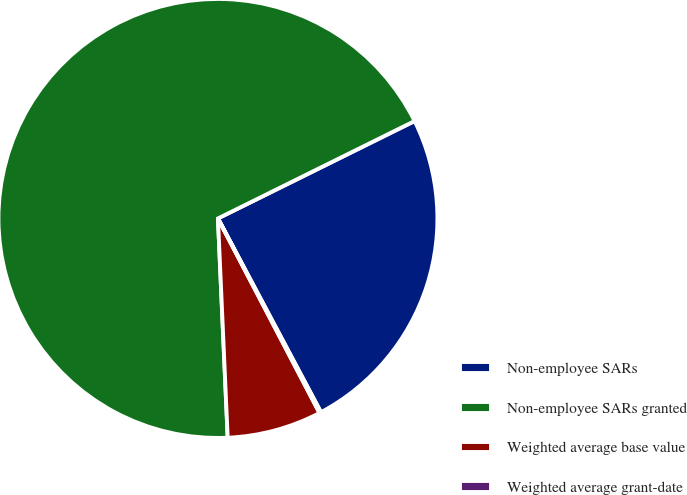<chart> <loc_0><loc_0><loc_500><loc_500><pie_chart><fcel>Non-employee SARs<fcel>Non-employee SARs granted<fcel>Weighted average base value<fcel>Weighted average grant-date<nl><fcel>24.54%<fcel>68.39%<fcel>6.95%<fcel>0.12%<nl></chart> 